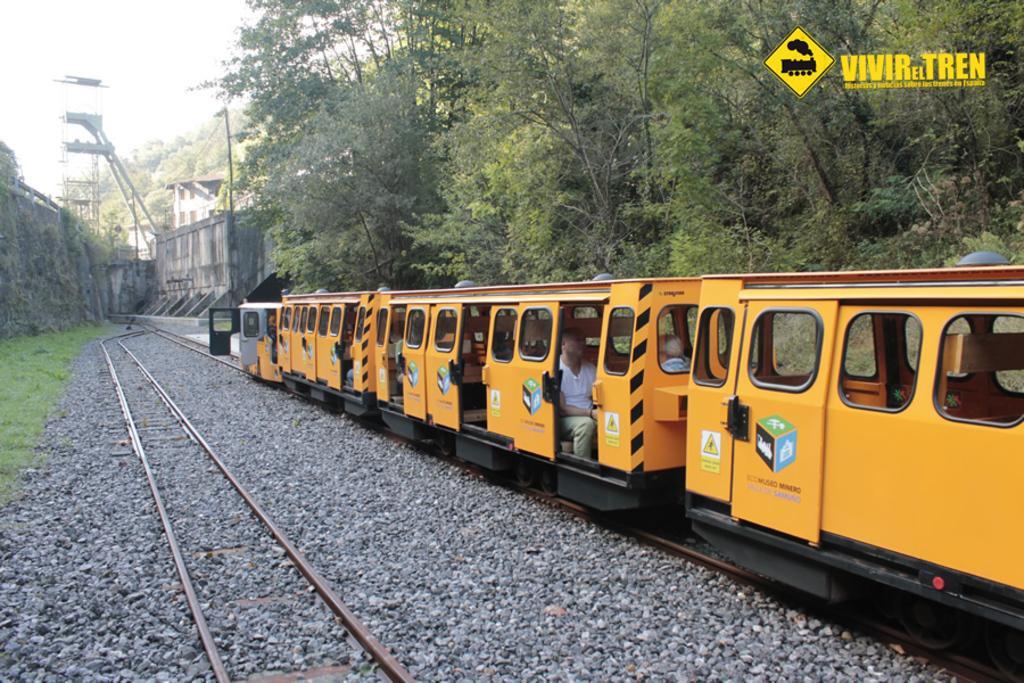Please provide a concise description of this image. There is a train moving on the track and behind the train there are plenty of trees and the train is of yellow color. 